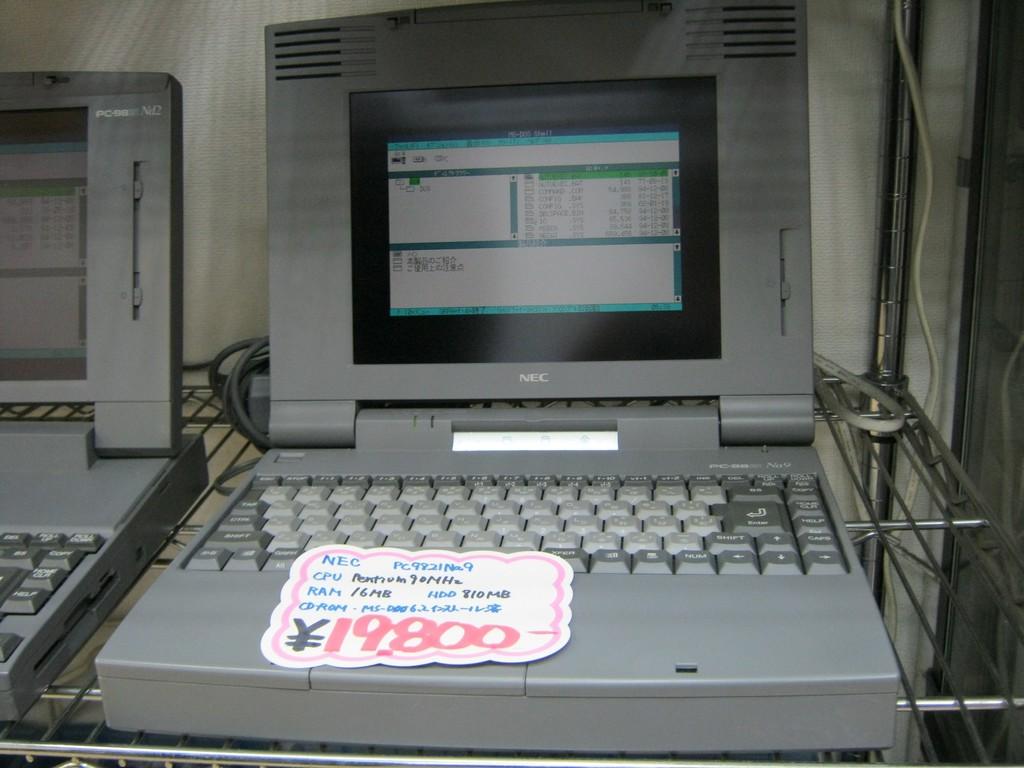How much is this?
Offer a terse response. 19,800. 